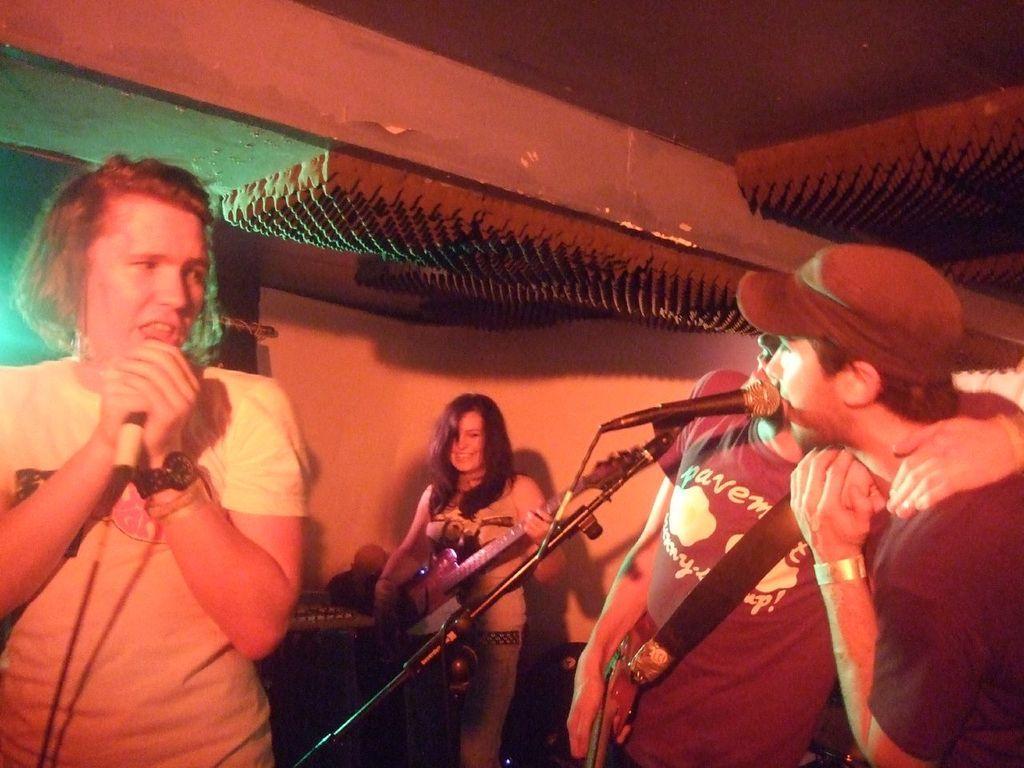Could you give a brief overview of what you see in this image? In this image we can see this three persons are standing at the mics and singing. In the background we can see this woman is holding a guitar and playing it. 